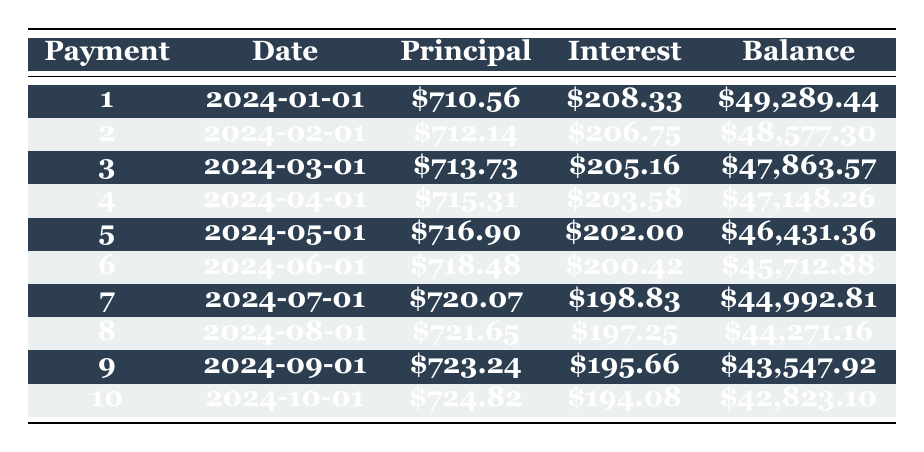What is the total principal payment in the first 10 months? To find the total principal payment, we add the principal payments from each of the 10 months. The total is calculated as follows: 710.56 + 712.14 + 713.73 + 715.31 + 716.90 + 718.48 + 720.07 + 721.65 + 723.24 + 724.82 = 7,500.06.
Answer: 7500.06 How much interest is paid in the first month? The table shows that the interest payment in the first month is provided as an explicit value, which is 208.33.
Answer: 208.33 Is the remaining balance after the 5th payment less than 45,000? The remaining balance after the 5th payment is 46,431.36, which is greater than 45,000. Therefore, the statement is false.
Answer: No What is the average monthly principal payment over the first 10 payments? To calculate the average monthly principal payment, we first sum the principal payments over the first 10 months: 710.56 + 712.14 + 713.73 + 715.31 + 716.90 + 718.48 + 720.07 + 721.65 + 723.24 + 724.82 = 7,500.06. Next, we divide this total by the number of payments (10): 7500.06 / 10 = 750.01.
Answer: 750.01 Which payment has the highest principal payment, and what is its value? By reviewing the principal payments listed, we can see that the largest payment occurs in the 10th month, which has a value of 724.82.
Answer: 724.82 What is the total interest paid in the 3rd and 4th months combined? For the 3rd month, the interest payment is 205.16 and for the 4th month, the interest payment is 203.58. Adding these amounts gives us a total: 205.16 + 203.58 = 408.74.
Answer: 408.74 By how much does the principal payment increase from the 1st to the 10th month? The principal payments for the 1st month and the 10th month are 710.56 and 724.82, respectively. The increase is calculated by subtracting the 1st month's payment from the 10th: 724.82 - 710.56 = 14.26.
Answer: 14.26 Is the interest payment in the 6th month less than the interest payment in the 2nd month? The interest payment in the 6th month is 200.42, while the payment in the 2nd month is 206.75. Since 200.42 is less than 206.75, the statement is true.
Answer: Yes What is the remaining balance after the 7th payment? The table explicitly shows that after the 7th payment, the remaining balance is 44,992.81.
Answer: 44992.81 